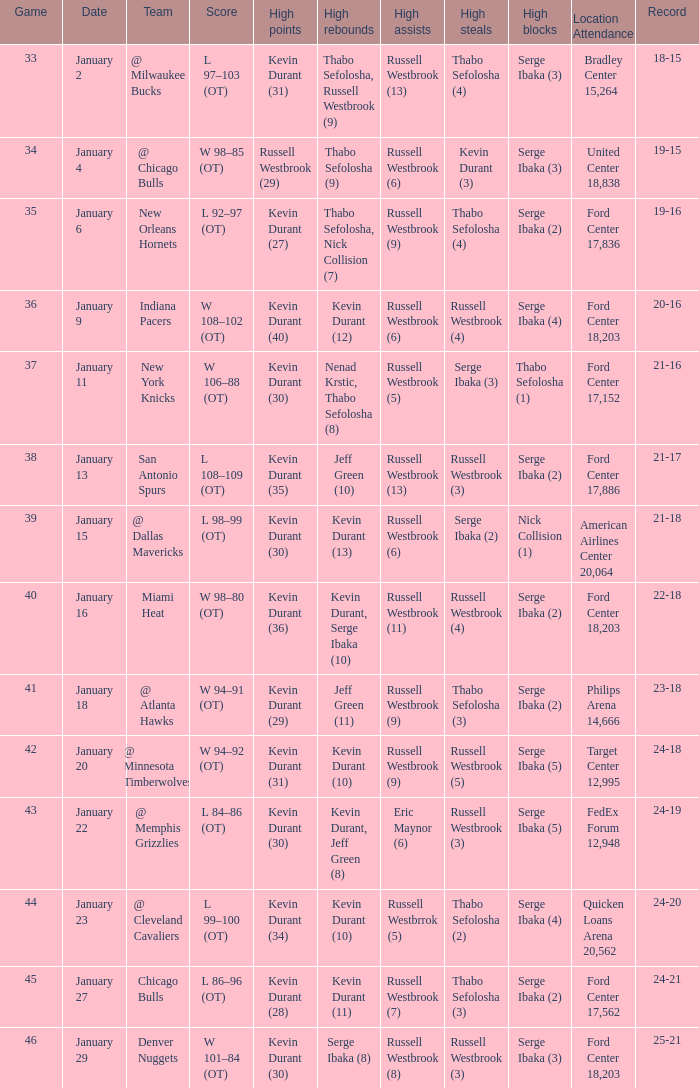Name the least game for january 29 46.0. 